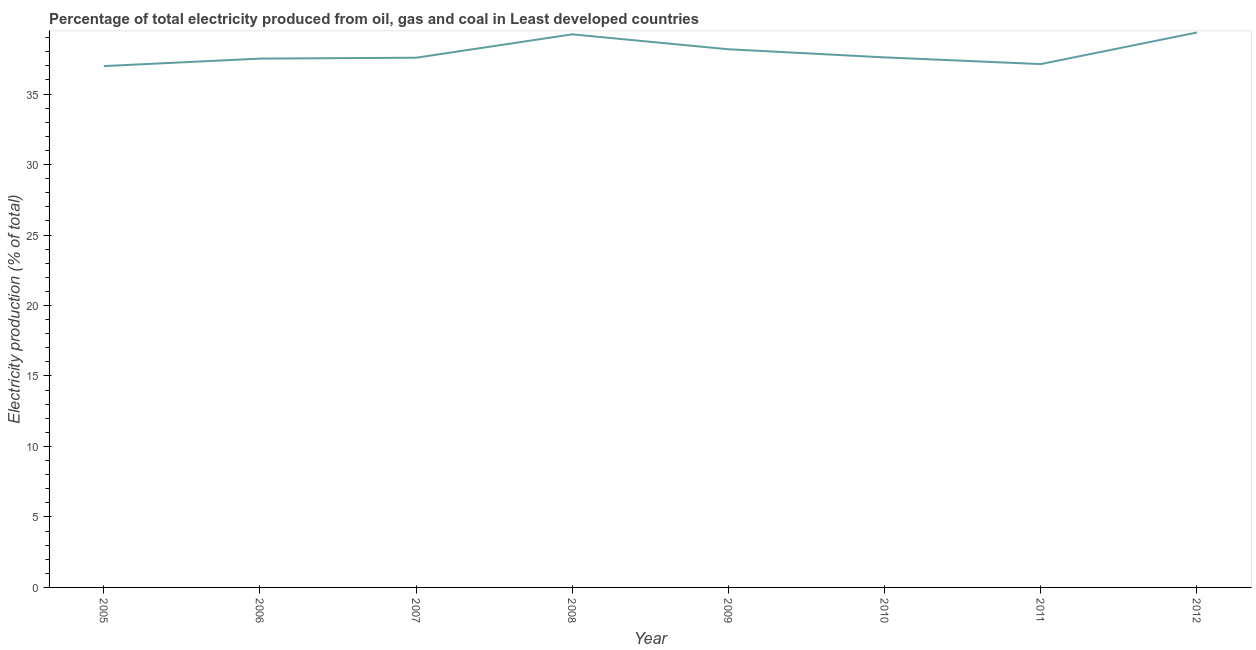What is the electricity production in 2011?
Offer a terse response. 37.12. Across all years, what is the maximum electricity production?
Make the answer very short. 39.37. Across all years, what is the minimum electricity production?
Your answer should be very brief. 36.98. In which year was the electricity production minimum?
Provide a short and direct response. 2005. What is the sum of the electricity production?
Offer a very short reply. 303.58. What is the difference between the electricity production in 2009 and 2011?
Your answer should be very brief. 1.05. What is the average electricity production per year?
Offer a terse response. 37.95. What is the median electricity production?
Your answer should be very brief. 37.59. In how many years, is the electricity production greater than 16 %?
Provide a succinct answer. 8. Do a majority of the years between 2006 and 2012 (inclusive) have electricity production greater than 11 %?
Provide a short and direct response. Yes. What is the ratio of the electricity production in 2010 to that in 2011?
Your answer should be very brief. 1.01. What is the difference between the highest and the second highest electricity production?
Make the answer very short. 0.13. Is the sum of the electricity production in 2010 and 2011 greater than the maximum electricity production across all years?
Your response must be concise. Yes. What is the difference between the highest and the lowest electricity production?
Offer a terse response. 2.38. In how many years, is the electricity production greater than the average electricity production taken over all years?
Keep it short and to the point. 3. How many lines are there?
Your response must be concise. 1. Does the graph contain any zero values?
Give a very brief answer. No. Does the graph contain grids?
Your answer should be very brief. No. What is the title of the graph?
Keep it short and to the point. Percentage of total electricity produced from oil, gas and coal in Least developed countries. What is the label or title of the X-axis?
Your answer should be compact. Year. What is the label or title of the Y-axis?
Provide a succinct answer. Electricity production (% of total). What is the Electricity production (% of total) in 2005?
Provide a succinct answer. 36.98. What is the Electricity production (% of total) of 2006?
Your answer should be very brief. 37.51. What is the Electricity production (% of total) in 2007?
Your answer should be compact. 37.58. What is the Electricity production (% of total) of 2008?
Provide a succinct answer. 39.24. What is the Electricity production (% of total) in 2009?
Provide a succinct answer. 38.18. What is the Electricity production (% of total) in 2010?
Keep it short and to the point. 37.6. What is the Electricity production (% of total) in 2011?
Keep it short and to the point. 37.12. What is the Electricity production (% of total) of 2012?
Your response must be concise. 39.37. What is the difference between the Electricity production (% of total) in 2005 and 2006?
Offer a very short reply. -0.53. What is the difference between the Electricity production (% of total) in 2005 and 2007?
Provide a succinct answer. -0.59. What is the difference between the Electricity production (% of total) in 2005 and 2008?
Offer a very short reply. -2.25. What is the difference between the Electricity production (% of total) in 2005 and 2009?
Your answer should be compact. -1.19. What is the difference between the Electricity production (% of total) in 2005 and 2010?
Your response must be concise. -0.62. What is the difference between the Electricity production (% of total) in 2005 and 2011?
Your answer should be compact. -0.14. What is the difference between the Electricity production (% of total) in 2005 and 2012?
Your answer should be compact. -2.38. What is the difference between the Electricity production (% of total) in 2006 and 2007?
Ensure brevity in your answer.  -0.06. What is the difference between the Electricity production (% of total) in 2006 and 2008?
Give a very brief answer. -1.72. What is the difference between the Electricity production (% of total) in 2006 and 2009?
Your response must be concise. -0.66. What is the difference between the Electricity production (% of total) in 2006 and 2010?
Provide a short and direct response. -0.09. What is the difference between the Electricity production (% of total) in 2006 and 2011?
Give a very brief answer. 0.39. What is the difference between the Electricity production (% of total) in 2006 and 2012?
Your answer should be very brief. -1.85. What is the difference between the Electricity production (% of total) in 2007 and 2008?
Offer a very short reply. -1.66. What is the difference between the Electricity production (% of total) in 2007 and 2009?
Make the answer very short. -0.6. What is the difference between the Electricity production (% of total) in 2007 and 2010?
Your answer should be very brief. -0.02. What is the difference between the Electricity production (% of total) in 2007 and 2011?
Your answer should be very brief. 0.45. What is the difference between the Electricity production (% of total) in 2007 and 2012?
Provide a succinct answer. -1.79. What is the difference between the Electricity production (% of total) in 2008 and 2009?
Keep it short and to the point. 1.06. What is the difference between the Electricity production (% of total) in 2008 and 2010?
Provide a short and direct response. 1.63. What is the difference between the Electricity production (% of total) in 2008 and 2011?
Make the answer very short. 2.11. What is the difference between the Electricity production (% of total) in 2008 and 2012?
Provide a short and direct response. -0.13. What is the difference between the Electricity production (% of total) in 2009 and 2010?
Provide a succinct answer. 0.58. What is the difference between the Electricity production (% of total) in 2009 and 2011?
Your answer should be very brief. 1.05. What is the difference between the Electricity production (% of total) in 2009 and 2012?
Keep it short and to the point. -1.19. What is the difference between the Electricity production (% of total) in 2010 and 2011?
Your answer should be very brief. 0.48. What is the difference between the Electricity production (% of total) in 2010 and 2012?
Offer a terse response. -1.76. What is the difference between the Electricity production (% of total) in 2011 and 2012?
Provide a short and direct response. -2.24. What is the ratio of the Electricity production (% of total) in 2005 to that in 2006?
Ensure brevity in your answer.  0.99. What is the ratio of the Electricity production (% of total) in 2005 to that in 2008?
Provide a short and direct response. 0.94. What is the ratio of the Electricity production (% of total) in 2005 to that in 2009?
Offer a very short reply. 0.97. What is the ratio of the Electricity production (% of total) in 2005 to that in 2011?
Give a very brief answer. 1. What is the ratio of the Electricity production (% of total) in 2005 to that in 2012?
Your answer should be very brief. 0.94. What is the ratio of the Electricity production (% of total) in 2006 to that in 2007?
Your response must be concise. 1. What is the ratio of the Electricity production (% of total) in 2006 to that in 2008?
Give a very brief answer. 0.96. What is the ratio of the Electricity production (% of total) in 2006 to that in 2011?
Provide a short and direct response. 1.01. What is the ratio of the Electricity production (% of total) in 2006 to that in 2012?
Keep it short and to the point. 0.95. What is the ratio of the Electricity production (% of total) in 2007 to that in 2008?
Ensure brevity in your answer.  0.96. What is the ratio of the Electricity production (% of total) in 2007 to that in 2009?
Keep it short and to the point. 0.98. What is the ratio of the Electricity production (% of total) in 2007 to that in 2010?
Give a very brief answer. 1. What is the ratio of the Electricity production (% of total) in 2007 to that in 2011?
Make the answer very short. 1.01. What is the ratio of the Electricity production (% of total) in 2007 to that in 2012?
Provide a succinct answer. 0.95. What is the ratio of the Electricity production (% of total) in 2008 to that in 2009?
Provide a succinct answer. 1.03. What is the ratio of the Electricity production (% of total) in 2008 to that in 2010?
Ensure brevity in your answer.  1.04. What is the ratio of the Electricity production (% of total) in 2008 to that in 2011?
Your response must be concise. 1.06. What is the ratio of the Electricity production (% of total) in 2008 to that in 2012?
Make the answer very short. 1. What is the ratio of the Electricity production (% of total) in 2009 to that in 2011?
Your response must be concise. 1.03. What is the ratio of the Electricity production (% of total) in 2009 to that in 2012?
Your response must be concise. 0.97. What is the ratio of the Electricity production (% of total) in 2010 to that in 2011?
Ensure brevity in your answer.  1.01. What is the ratio of the Electricity production (% of total) in 2010 to that in 2012?
Keep it short and to the point. 0.95. What is the ratio of the Electricity production (% of total) in 2011 to that in 2012?
Offer a very short reply. 0.94. 